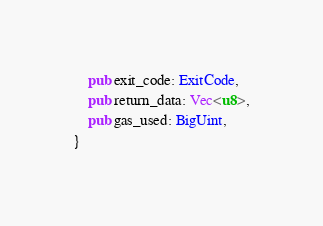Convert code to text. <code><loc_0><loc_0><loc_500><loc_500><_Rust_>    pub exit_code: ExitCode,
    pub return_data: Vec<u8>,
    pub gas_used: BigUint,
}
</code> 